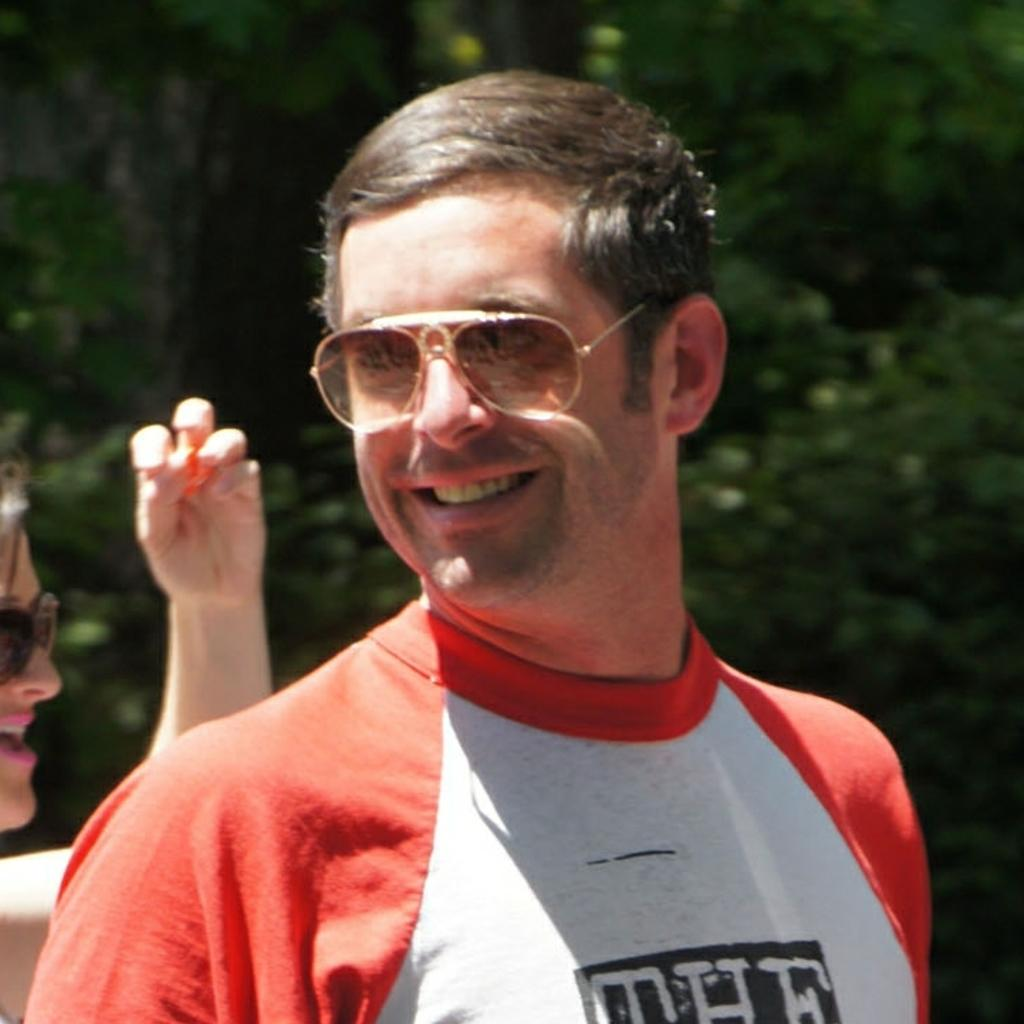How many people are present in the image? There are two people in the image. What can be seen in the background of the image? There are trees in the background of the image. What type of amusement can be seen in the image? There is no amusement present in the image; it features two people and trees in the background. What is causing the people to slip in the image? There is no indication of anyone slipping in the image. 